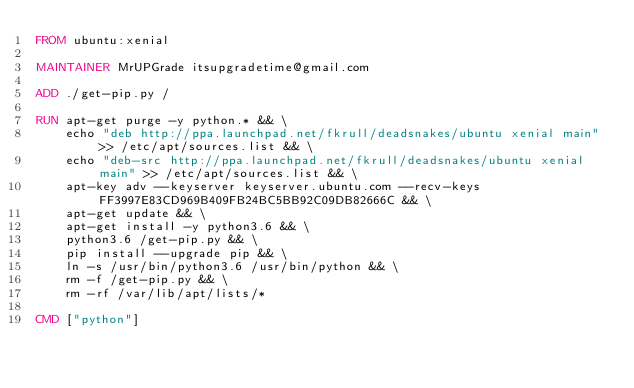Convert code to text. <code><loc_0><loc_0><loc_500><loc_500><_Dockerfile_>FROM ubuntu:xenial

MAINTAINER MrUPGrade itsupgradetime@gmail.com

ADD ./get-pip.py /

RUN apt-get purge -y python.* && \
    echo "deb http://ppa.launchpad.net/fkrull/deadsnakes/ubuntu xenial main" >> /etc/apt/sources.list && \
    echo "deb-src http://ppa.launchpad.net/fkrull/deadsnakes/ubuntu xenial main" >> /etc/apt/sources.list && \
    apt-key adv --keyserver keyserver.ubuntu.com --recv-keys FF3997E83CD969B409FB24BC5BB92C09DB82666C && \
    apt-get update && \
    apt-get install -y python3.6 && \
    python3.6 /get-pip.py && \
    pip install --upgrade pip && \
    ln -s /usr/bin/python3.6 /usr/bin/python && \
    rm -f /get-pip.py && \
    rm -rf /var/lib/apt/lists/*

CMD ["python"]
</code> 